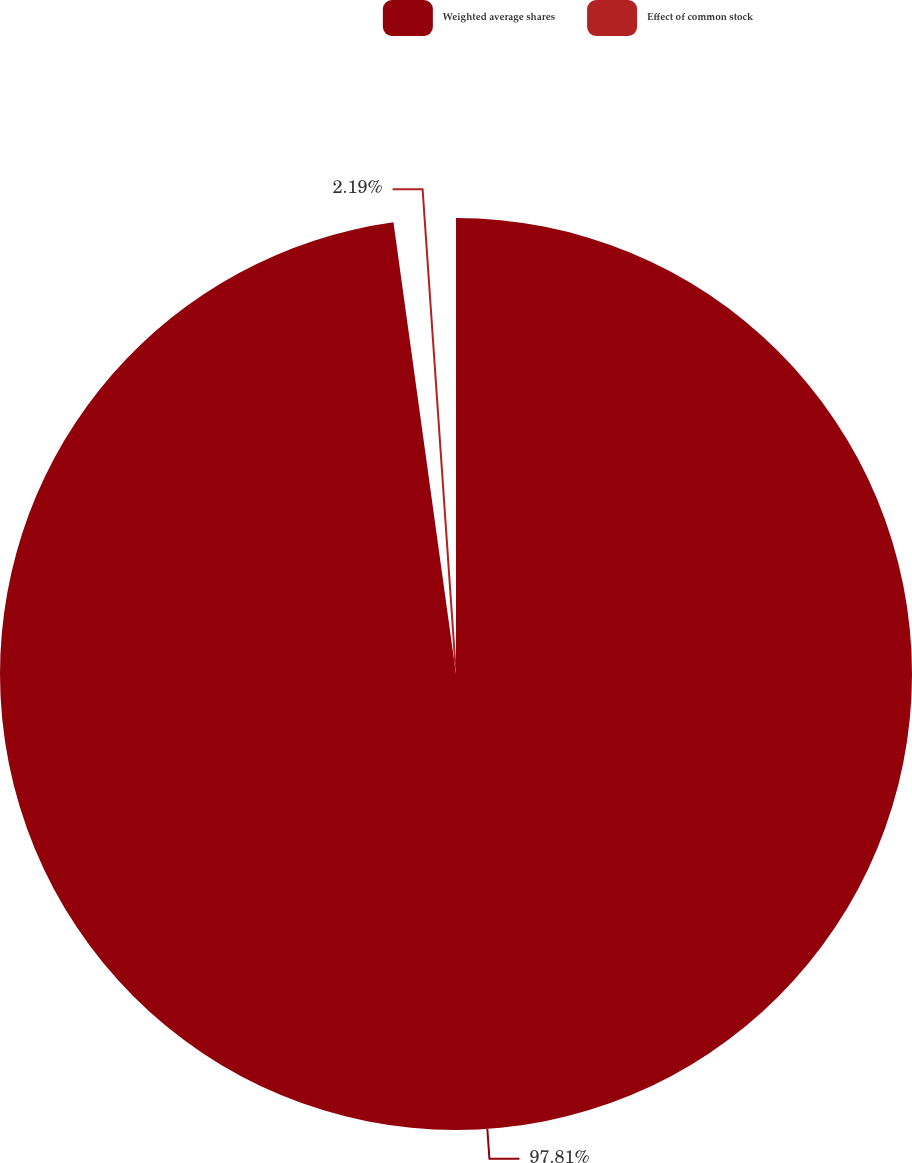Convert chart to OTSL. <chart><loc_0><loc_0><loc_500><loc_500><pie_chart><fcel>Weighted average shares<fcel>Effect of common stock<nl><fcel>97.81%<fcel>2.19%<nl></chart> 